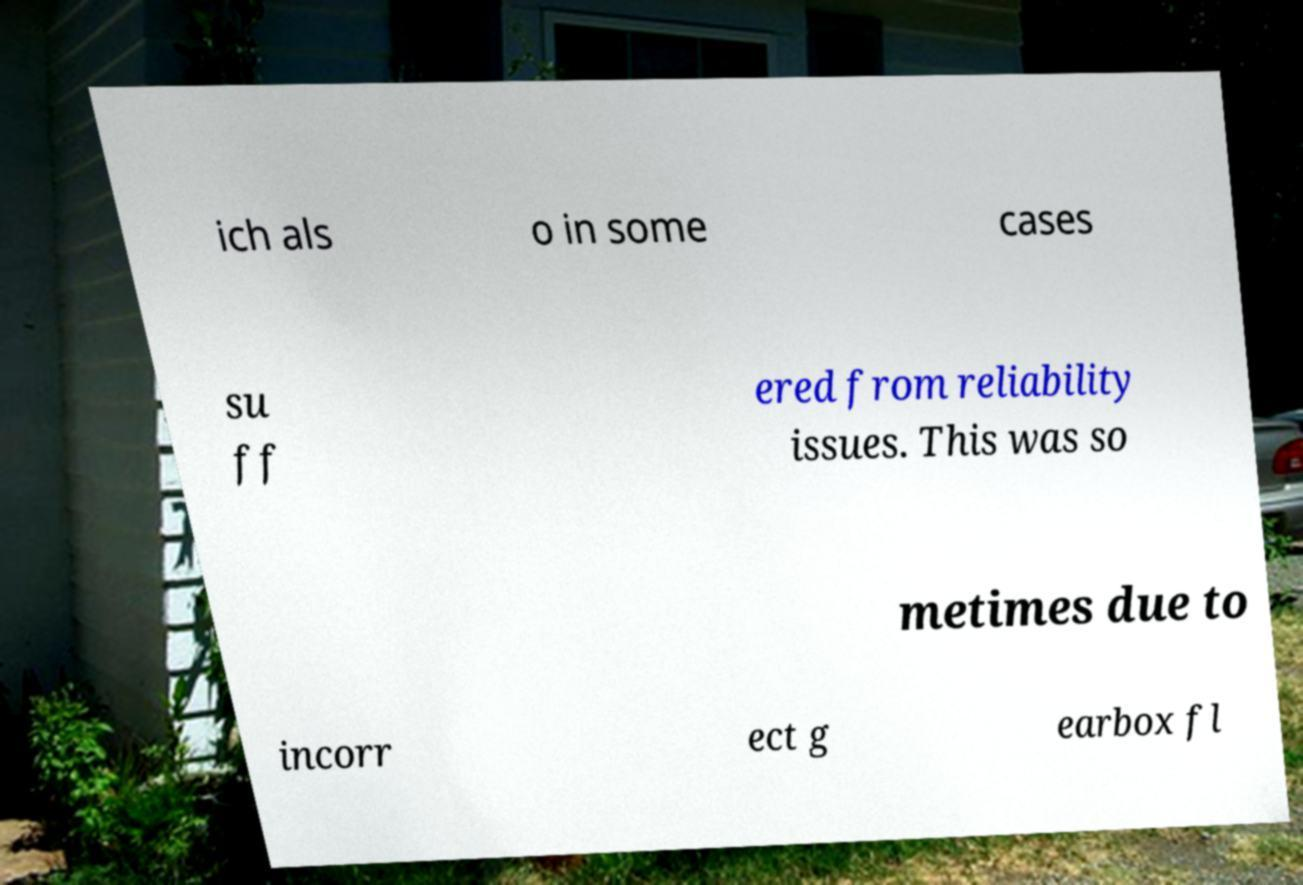Can you read and provide the text displayed in the image?This photo seems to have some interesting text. Can you extract and type it out for me? ich als o in some cases su ff ered from reliability issues. This was so metimes due to incorr ect g earbox fl 